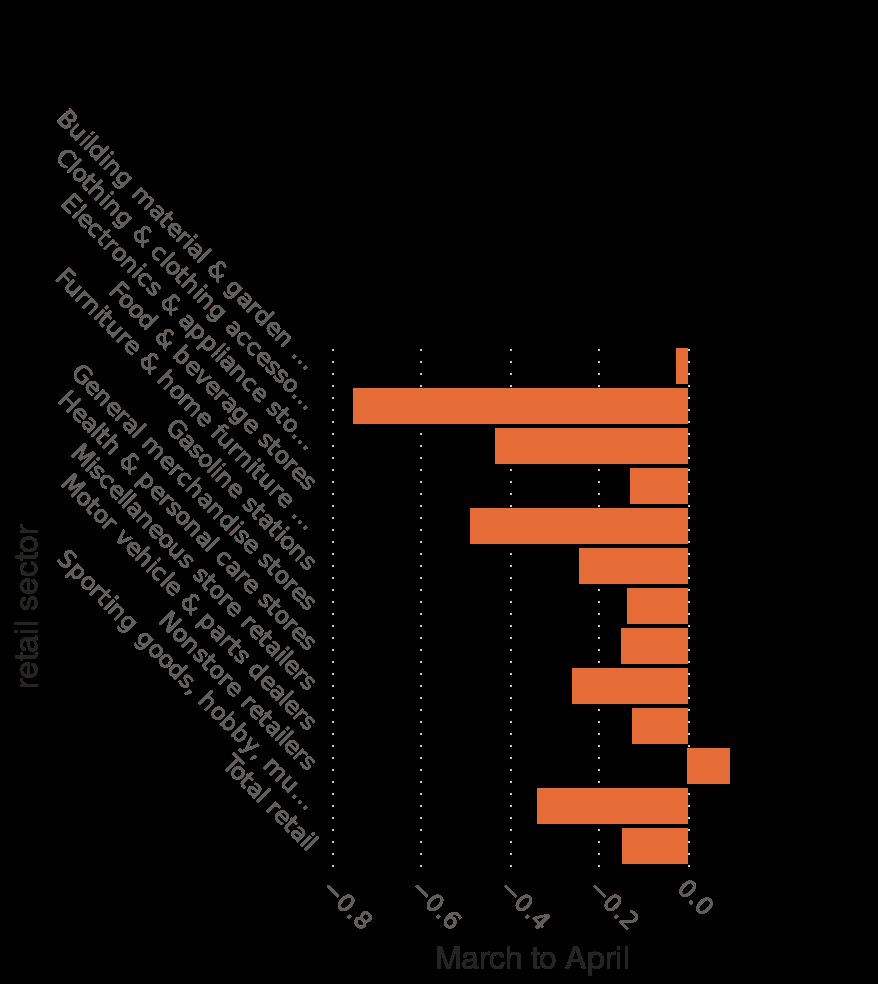<image>
What industry was most affected by the coronavirus in the United States between March and April 2020? The retail sector of clothing and clothing accessories. Offer a thorough analysis of the image. Sales decreased in all sectors from March to April with the clothing and clothing accessories sector being the worst hit. However non store retailers went against the trend and had an increase in sales. What was the impact of the coronavirus on the retail sector of clothing and clothing accessories in the United States? It had the most negative impact. 